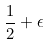Convert formula to latex. <formula><loc_0><loc_0><loc_500><loc_500>\frac { 1 } { 2 } + \epsilon</formula> 